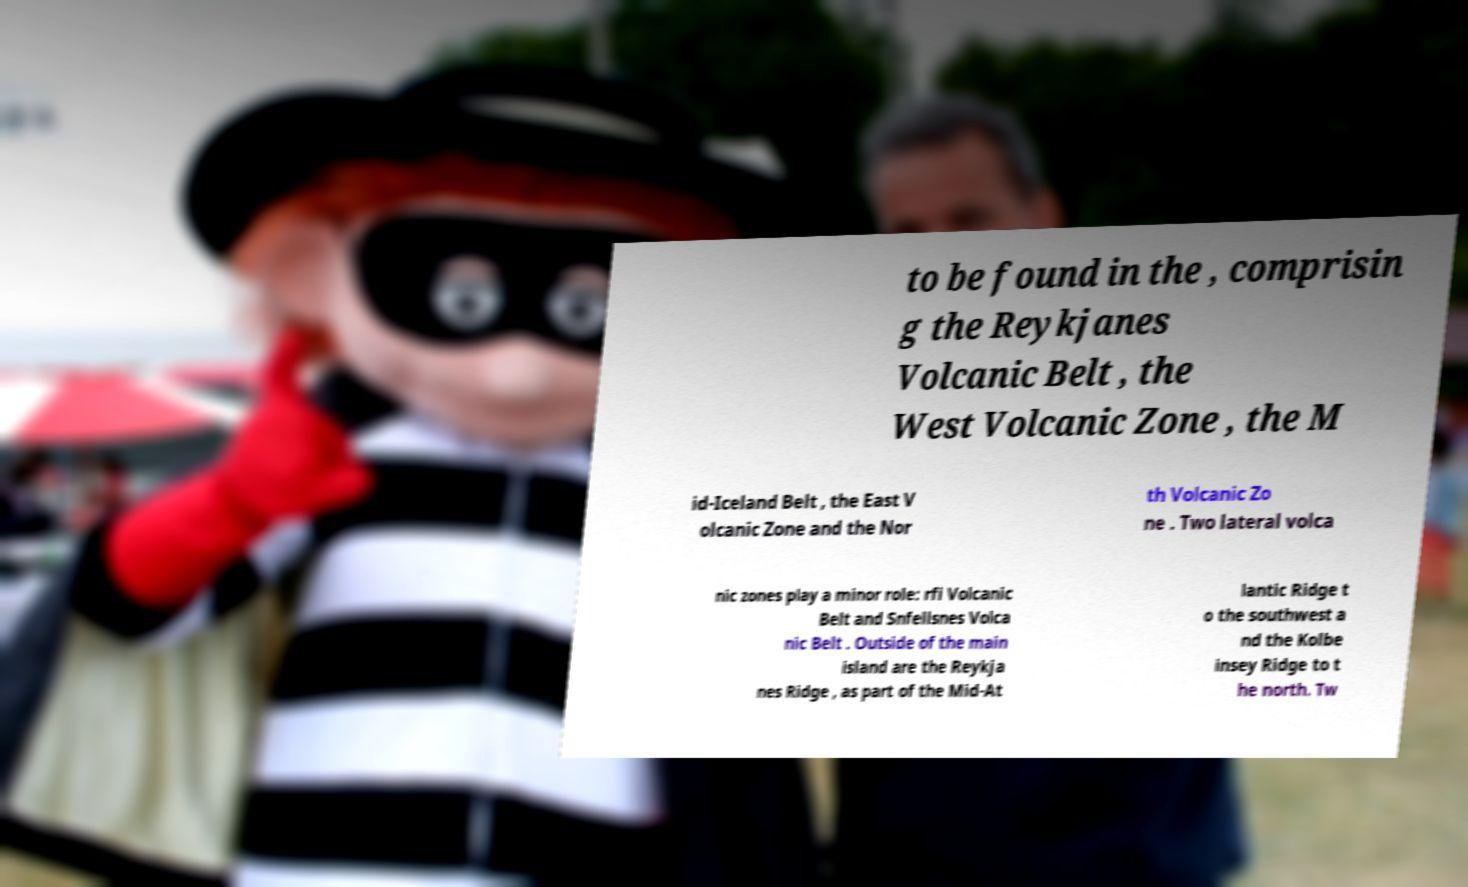Can you read and provide the text displayed in the image?This photo seems to have some interesting text. Can you extract and type it out for me? to be found in the , comprisin g the Reykjanes Volcanic Belt , the West Volcanic Zone , the M id-Iceland Belt , the East V olcanic Zone and the Nor th Volcanic Zo ne . Two lateral volca nic zones play a minor role: rfi Volcanic Belt and Snfellsnes Volca nic Belt . Outside of the main island are the Reykja nes Ridge , as part of the Mid-At lantic Ridge t o the southwest a nd the Kolbe insey Ridge to t he north. Tw 